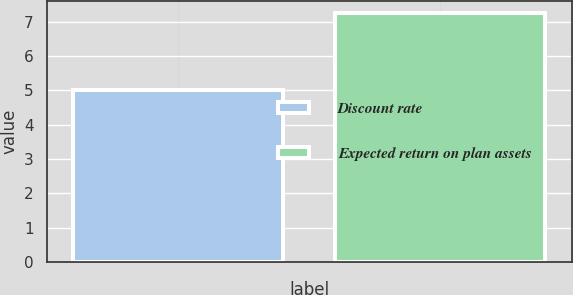Convert chart. <chart><loc_0><loc_0><loc_500><loc_500><bar_chart><fcel>Discount rate<fcel>Expected return on plan assets<nl><fcel>5<fcel>7.25<nl></chart> 